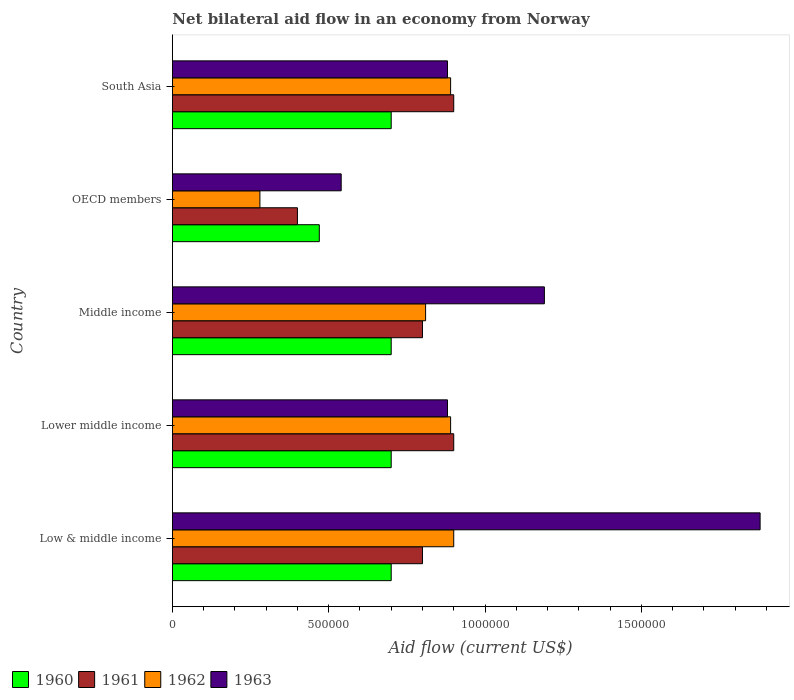How many different coloured bars are there?
Make the answer very short. 4. How many groups of bars are there?
Your response must be concise. 5. Are the number of bars per tick equal to the number of legend labels?
Your answer should be compact. Yes. In which country was the net bilateral aid flow in 1962 maximum?
Provide a succinct answer. Low & middle income. What is the total net bilateral aid flow in 1963 in the graph?
Provide a succinct answer. 5.37e+06. What is the average net bilateral aid flow in 1962 per country?
Your answer should be compact. 7.54e+05. What is the difference between the net bilateral aid flow in 1960 and net bilateral aid flow in 1962 in South Asia?
Give a very brief answer. -1.90e+05. In how many countries, is the net bilateral aid flow in 1961 greater than 200000 US$?
Your answer should be compact. 5. What is the ratio of the net bilateral aid flow in 1963 in OECD members to that in South Asia?
Give a very brief answer. 0.61. Is the net bilateral aid flow in 1961 in Low & middle income less than that in OECD members?
Offer a very short reply. No. What is the difference between the highest and the second highest net bilateral aid flow in 1960?
Offer a terse response. 0. What is the difference between the highest and the lowest net bilateral aid flow in 1962?
Offer a terse response. 6.20e+05. Is the sum of the net bilateral aid flow in 1963 in Low & middle income and South Asia greater than the maximum net bilateral aid flow in 1960 across all countries?
Provide a short and direct response. Yes. What does the 1st bar from the top in Low & middle income represents?
Offer a very short reply. 1963. How many bars are there?
Provide a succinct answer. 20. How many countries are there in the graph?
Offer a terse response. 5. Are the values on the major ticks of X-axis written in scientific E-notation?
Your response must be concise. No. Does the graph contain any zero values?
Provide a short and direct response. No. Does the graph contain grids?
Offer a very short reply. No. Where does the legend appear in the graph?
Make the answer very short. Bottom left. How are the legend labels stacked?
Offer a terse response. Horizontal. What is the title of the graph?
Keep it short and to the point. Net bilateral aid flow in an economy from Norway. What is the label or title of the Y-axis?
Your answer should be compact. Country. What is the Aid flow (current US$) in 1961 in Low & middle income?
Your answer should be very brief. 8.00e+05. What is the Aid flow (current US$) of 1962 in Low & middle income?
Your response must be concise. 9.00e+05. What is the Aid flow (current US$) in 1963 in Low & middle income?
Offer a very short reply. 1.88e+06. What is the Aid flow (current US$) of 1960 in Lower middle income?
Your answer should be compact. 7.00e+05. What is the Aid flow (current US$) of 1961 in Lower middle income?
Ensure brevity in your answer.  9.00e+05. What is the Aid flow (current US$) of 1962 in Lower middle income?
Provide a short and direct response. 8.90e+05. What is the Aid flow (current US$) in 1963 in Lower middle income?
Give a very brief answer. 8.80e+05. What is the Aid flow (current US$) in 1962 in Middle income?
Your answer should be compact. 8.10e+05. What is the Aid flow (current US$) in 1963 in Middle income?
Ensure brevity in your answer.  1.19e+06. What is the Aid flow (current US$) of 1960 in OECD members?
Offer a terse response. 4.70e+05. What is the Aid flow (current US$) in 1963 in OECD members?
Provide a succinct answer. 5.40e+05. What is the Aid flow (current US$) of 1960 in South Asia?
Your answer should be compact. 7.00e+05. What is the Aid flow (current US$) in 1961 in South Asia?
Your answer should be compact. 9.00e+05. What is the Aid flow (current US$) of 1962 in South Asia?
Provide a short and direct response. 8.90e+05. What is the Aid flow (current US$) in 1963 in South Asia?
Your answer should be very brief. 8.80e+05. Across all countries, what is the maximum Aid flow (current US$) in 1962?
Keep it short and to the point. 9.00e+05. Across all countries, what is the maximum Aid flow (current US$) of 1963?
Your response must be concise. 1.88e+06. Across all countries, what is the minimum Aid flow (current US$) in 1961?
Your answer should be very brief. 4.00e+05. Across all countries, what is the minimum Aid flow (current US$) in 1963?
Give a very brief answer. 5.40e+05. What is the total Aid flow (current US$) of 1960 in the graph?
Provide a succinct answer. 3.27e+06. What is the total Aid flow (current US$) of 1961 in the graph?
Provide a succinct answer. 3.80e+06. What is the total Aid flow (current US$) in 1962 in the graph?
Make the answer very short. 3.77e+06. What is the total Aid flow (current US$) of 1963 in the graph?
Give a very brief answer. 5.37e+06. What is the difference between the Aid flow (current US$) in 1960 in Low & middle income and that in Lower middle income?
Ensure brevity in your answer.  0. What is the difference between the Aid flow (current US$) of 1962 in Low & middle income and that in Lower middle income?
Offer a terse response. 10000. What is the difference between the Aid flow (current US$) in 1963 in Low & middle income and that in Lower middle income?
Your answer should be very brief. 1.00e+06. What is the difference between the Aid flow (current US$) in 1961 in Low & middle income and that in Middle income?
Provide a succinct answer. 0. What is the difference between the Aid flow (current US$) in 1963 in Low & middle income and that in Middle income?
Offer a very short reply. 6.90e+05. What is the difference between the Aid flow (current US$) in 1960 in Low & middle income and that in OECD members?
Make the answer very short. 2.30e+05. What is the difference between the Aid flow (current US$) of 1962 in Low & middle income and that in OECD members?
Your answer should be compact. 6.20e+05. What is the difference between the Aid flow (current US$) of 1963 in Low & middle income and that in OECD members?
Offer a terse response. 1.34e+06. What is the difference between the Aid flow (current US$) of 1962 in Low & middle income and that in South Asia?
Your answer should be very brief. 10000. What is the difference between the Aid flow (current US$) in 1962 in Lower middle income and that in Middle income?
Offer a very short reply. 8.00e+04. What is the difference between the Aid flow (current US$) of 1963 in Lower middle income and that in Middle income?
Your answer should be very brief. -3.10e+05. What is the difference between the Aid flow (current US$) in 1963 in Lower middle income and that in OECD members?
Your answer should be compact. 3.40e+05. What is the difference between the Aid flow (current US$) of 1960 in Lower middle income and that in South Asia?
Your answer should be very brief. 0. What is the difference between the Aid flow (current US$) in 1962 in Lower middle income and that in South Asia?
Offer a very short reply. 0. What is the difference between the Aid flow (current US$) in 1961 in Middle income and that in OECD members?
Provide a short and direct response. 4.00e+05. What is the difference between the Aid flow (current US$) of 1962 in Middle income and that in OECD members?
Make the answer very short. 5.30e+05. What is the difference between the Aid flow (current US$) of 1963 in Middle income and that in OECD members?
Your answer should be very brief. 6.50e+05. What is the difference between the Aid flow (current US$) of 1960 in Middle income and that in South Asia?
Provide a succinct answer. 0. What is the difference between the Aid flow (current US$) of 1961 in Middle income and that in South Asia?
Make the answer very short. -1.00e+05. What is the difference between the Aid flow (current US$) in 1962 in Middle income and that in South Asia?
Offer a terse response. -8.00e+04. What is the difference between the Aid flow (current US$) in 1961 in OECD members and that in South Asia?
Provide a short and direct response. -5.00e+05. What is the difference between the Aid flow (current US$) in 1962 in OECD members and that in South Asia?
Provide a short and direct response. -6.10e+05. What is the difference between the Aid flow (current US$) in 1960 in Low & middle income and the Aid flow (current US$) in 1961 in Lower middle income?
Offer a very short reply. -2.00e+05. What is the difference between the Aid flow (current US$) of 1961 in Low & middle income and the Aid flow (current US$) of 1962 in Lower middle income?
Keep it short and to the point. -9.00e+04. What is the difference between the Aid flow (current US$) in 1961 in Low & middle income and the Aid flow (current US$) in 1963 in Lower middle income?
Offer a very short reply. -8.00e+04. What is the difference between the Aid flow (current US$) of 1962 in Low & middle income and the Aid flow (current US$) of 1963 in Lower middle income?
Give a very brief answer. 2.00e+04. What is the difference between the Aid flow (current US$) of 1960 in Low & middle income and the Aid flow (current US$) of 1963 in Middle income?
Offer a terse response. -4.90e+05. What is the difference between the Aid flow (current US$) in 1961 in Low & middle income and the Aid flow (current US$) in 1962 in Middle income?
Offer a very short reply. -10000. What is the difference between the Aid flow (current US$) of 1961 in Low & middle income and the Aid flow (current US$) of 1963 in Middle income?
Your answer should be compact. -3.90e+05. What is the difference between the Aid flow (current US$) in 1960 in Low & middle income and the Aid flow (current US$) in 1962 in OECD members?
Your answer should be very brief. 4.20e+05. What is the difference between the Aid flow (current US$) of 1961 in Low & middle income and the Aid flow (current US$) of 1962 in OECD members?
Ensure brevity in your answer.  5.20e+05. What is the difference between the Aid flow (current US$) of 1961 in Low & middle income and the Aid flow (current US$) of 1963 in OECD members?
Make the answer very short. 2.60e+05. What is the difference between the Aid flow (current US$) in 1960 in Low & middle income and the Aid flow (current US$) in 1961 in South Asia?
Give a very brief answer. -2.00e+05. What is the difference between the Aid flow (current US$) of 1960 in Low & middle income and the Aid flow (current US$) of 1963 in South Asia?
Make the answer very short. -1.80e+05. What is the difference between the Aid flow (current US$) in 1961 in Low & middle income and the Aid flow (current US$) in 1962 in South Asia?
Your response must be concise. -9.00e+04. What is the difference between the Aid flow (current US$) in 1961 in Low & middle income and the Aid flow (current US$) in 1963 in South Asia?
Your response must be concise. -8.00e+04. What is the difference between the Aid flow (current US$) of 1960 in Lower middle income and the Aid flow (current US$) of 1961 in Middle income?
Give a very brief answer. -1.00e+05. What is the difference between the Aid flow (current US$) in 1960 in Lower middle income and the Aid flow (current US$) in 1963 in Middle income?
Ensure brevity in your answer.  -4.90e+05. What is the difference between the Aid flow (current US$) in 1961 in Lower middle income and the Aid flow (current US$) in 1962 in Middle income?
Offer a terse response. 9.00e+04. What is the difference between the Aid flow (current US$) of 1960 in Lower middle income and the Aid flow (current US$) of 1961 in OECD members?
Keep it short and to the point. 3.00e+05. What is the difference between the Aid flow (current US$) in 1961 in Lower middle income and the Aid flow (current US$) in 1962 in OECD members?
Make the answer very short. 6.20e+05. What is the difference between the Aid flow (current US$) in 1961 in Lower middle income and the Aid flow (current US$) in 1963 in OECD members?
Give a very brief answer. 3.60e+05. What is the difference between the Aid flow (current US$) in 1962 in Lower middle income and the Aid flow (current US$) in 1963 in OECD members?
Offer a very short reply. 3.50e+05. What is the difference between the Aid flow (current US$) of 1960 in Lower middle income and the Aid flow (current US$) of 1963 in South Asia?
Ensure brevity in your answer.  -1.80e+05. What is the difference between the Aid flow (current US$) of 1961 in Lower middle income and the Aid flow (current US$) of 1962 in South Asia?
Provide a succinct answer. 10000. What is the difference between the Aid flow (current US$) of 1961 in Lower middle income and the Aid flow (current US$) of 1963 in South Asia?
Provide a short and direct response. 2.00e+04. What is the difference between the Aid flow (current US$) in 1961 in Middle income and the Aid flow (current US$) in 1962 in OECD members?
Offer a very short reply. 5.20e+05. What is the difference between the Aid flow (current US$) of 1962 in Middle income and the Aid flow (current US$) of 1963 in South Asia?
Offer a terse response. -7.00e+04. What is the difference between the Aid flow (current US$) in 1960 in OECD members and the Aid flow (current US$) in 1961 in South Asia?
Your response must be concise. -4.30e+05. What is the difference between the Aid flow (current US$) in 1960 in OECD members and the Aid flow (current US$) in 1962 in South Asia?
Offer a terse response. -4.20e+05. What is the difference between the Aid flow (current US$) in 1960 in OECD members and the Aid flow (current US$) in 1963 in South Asia?
Provide a succinct answer. -4.10e+05. What is the difference between the Aid flow (current US$) in 1961 in OECD members and the Aid flow (current US$) in 1962 in South Asia?
Keep it short and to the point. -4.90e+05. What is the difference between the Aid flow (current US$) in 1961 in OECD members and the Aid flow (current US$) in 1963 in South Asia?
Ensure brevity in your answer.  -4.80e+05. What is the difference between the Aid flow (current US$) in 1962 in OECD members and the Aid flow (current US$) in 1963 in South Asia?
Offer a very short reply. -6.00e+05. What is the average Aid flow (current US$) of 1960 per country?
Give a very brief answer. 6.54e+05. What is the average Aid flow (current US$) of 1961 per country?
Provide a succinct answer. 7.60e+05. What is the average Aid flow (current US$) in 1962 per country?
Make the answer very short. 7.54e+05. What is the average Aid flow (current US$) in 1963 per country?
Your answer should be very brief. 1.07e+06. What is the difference between the Aid flow (current US$) of 1960 and Aid flow (current US$) of 1962 in Low & middle income?
Offer a terse response. -2.00e+05. What is the difference between the Aid flow (current US$) in 1960 and Aid flow (current US$) in 1963 in Low & middle income?
Offer a very short reply. -1.18e+06. What is the difference between the Aid flow (current US$) in 1961 and Aid flow (current US$) in 1963 in Low & middle income?
Offer a very short reply. -1.08e+06. What is the difference between the Aid flow (current US$) in 1962 and Aid flow (current US$) in 1963 in Low & middle income?
Your response must be concise. -9.80e+05. What is the difference between the Aid flow (current US$) in 1960 and Aid flow (current US$) in 1961 in Lower middle income?
Your response must be concise. -2.00e+05. What is the difference between the Aid flow (current US$) of 1960 and Aid flow (current US$) of 1963 in Middle income?
Ensure brevity in your answer.  -4.90e+05. What is the difference between the Aid flow (current US$) in 1961 and Aid flow (current US$) in 1962 in Middle income?
Make the answer very short. -10000. What is the difference between the Aid flow (current US$) of 1961 and Aid flow (current US$) of 1963 in Middle income?
Provide a short and direct response. -3.90e+05. What is the difference between the Aid flow (current US$) of 1962 and Aid flow (current US$) of 1963 in Middle income?
Ensure brevity in your answer.  -3.80e+05. What is the difference between the Aid flow (current US$) of 1960 and Aid flow (current US$) of 1961 in OECD members?
Offer a terse response. 7.00e+04. What is the difference between the Aid flow (current US$) of 1961 and Aid flow (current US$) of 1962 in OECD members?
Give a very brief answer. 1.20e+05. What is the difference between the Aid flow (current US$) in 1962 and Aid flow (current US$) in 1963 in OECD members?
Give a very brief answer. -2.60e+05. What is the difference between the Aid flow (current US$) of 1960 and Aid flow (current US$) of 1961 in South Asia?
Keep it short and to the point. -2.00e+05. What is the difference between the Aid flow (current US$) of 1960 and Aid flow (current US$) of 1962 in South Asia?
Keep it short and to the point. -1.90e+05. What is the difference between the Aid flow (current US$) in 1961 and Aid flow (current US$) in 1963 in South Asia?
Your answer should be compact. 2.00e+04. What is the ratio of the Aid flow (current US$) in 1960 in Low & middle income to that in Lower middle income?
Provide a succinct answer. 1. What is the ratio of the Aid flow (current US$) of 1961 in Low & middle income to that in Lower middle income?
Your response must be concise. 0.89. What is the ratio of the Aid flow (current US$) of 1962 in Low & middle income to that in Lower middle income?
Provide a succinct answer. 1.01. What is the ratio of the Aid flow (current US$) in 1963 in Low & middle income to that in Lower middle income?
Give a very brief answer. 2.14. What is the ratio of the Aid flow (current US$) of 1962 in Low & middle income to that in Middle income?
Your answer should be very brief. 1.11. What is the ratio of the Aid flow (current US$) of 1963 in Low & middle income to that in Middle income?
Provide a succinct answer. 1.58. What is the ratio of the Aid flow (current US$) of 1960 in Low & middle income to that in OECD members?
Your answer should be compact. 1.49. What is the ratio of the Aid flow (current US$) in 1962 in Low & middle income to that in OECD members?
Keep it short and to the point. 3.21. What is the ratio of the Aid flow (current US$) in 1963 in Low & middle income to that in OECD members?
Provide a short and direct response. 3.48. What is the ratio of the Aid flow (current US$) in 1962 in Low & middle income to that in South Asia?
Provide a succinct answer. 1.01. What is the ratio of the Aid flow (current US$) of 1963 in Low & middle income to that in South Asia?
Your response must be concise. 2.14. What is the ratio of the Aid flow (current US$) in 1961 in Lower middle income to that in Middle income?
Offer a terse response. 1.12. What is the ratio of the Aid flow (current US$) in 1962 in Lower middle income to that in Middle income?
Ensure brevity in your answer.  1.1. What is the ratio of the Aid flow (current US$) in 1963 in Lower middle income to that in Middle income?
Your answer should be compact. 0.74. What is the ratio of the Aid flow (current US$) of 1960 in Lower middle income to that in OECD members?
Offer a very short reply. 1.49. What is the ratio of the Aid flow (current US$) of 1961 in Lower middle income to that in OECD members?
Offer a terse response. 2.25. What is the ratio of the Aid flow (current US$) in 1962 in Lower middle income to that in OECD members?
Provide a succinct answer. 3.18. What is the ratio of the Aid flow (current US$) in 1963 in Lower middle income to that in OECD members?
Your answer should be very brief. 1.63. What is the ratio of the Aid flow (current US$) in 1962 in Lower middle income to that in South Asia?
Offer a very short reply. 1. What is the ratio of the Aid flow (current US$) of 1960 in Middle income to that in OECD members?
Provide a short and direct response. 1.49. What is the ratio of the Aid flow (current US$) of 1962 in Middle income to that in OECD members?
Make the answer very short. 2.89. What is the ratio of the Aid flow (current US$) of 1963 in Middle income to that in OECD members?
Ensure brevity in your answer.  2.2. What is the ratio of the Aid flow (current US$) of 1962 in Middle income to that in South Asia?
Keep it short and to the point. 0.91. What is the ratio of the Aid flow (current US$) of 1963 in Middle income to that in South Asia?
Ensure brevity in your answer.  1.35. What is the ratio of the Aid flow (current US$) in 1960 in OECD members to that in South Asia?
Provide a short and direct response. 0.67. What is the ratio of the Aid flow (current US$) in 1961 in OECD members to that in South Asia?
Your answer should be compact. 0.44. What is the ratio of the Aid flow (current US$) in 1962 in OECD members to that in South Asia?
Your response must be concise. 0.31. What is the ratio of the Aid flow (current US$) in 1963 in OECD members to that in South Asia?
Your answer should be compact. 0.61. What is the difference between the highest and the second highest Aid flow (current US$) of 1960?
Offer a very short reply. 0. What is the difference between the highest and the second highest Aid flow (current US$) of 1962?
Your answer should be compact. 10000. What is the difference between the highest and the second highest Aid flow (current US$) of 1963?
Provide a short and direct response. 6.90e+05. What is the difference between the highest and the lowest Aid flow (current US$) in 1960?
Ensure brevity in your answer.  2.30e+05. What is the difference between the highest and the lowest Aid flow (current US$) in 1961?
Your answer should be very brief. 5.00e+05. What is the difference between the highest and the lowest Aid flow (current US$) of 1962?
Ensure brevity in your answer.  6.20e+05. What is the difference between the highest and the lowest Aid flow (current US$) in 1963?
Your answer should be compact. 1.34e+06. 